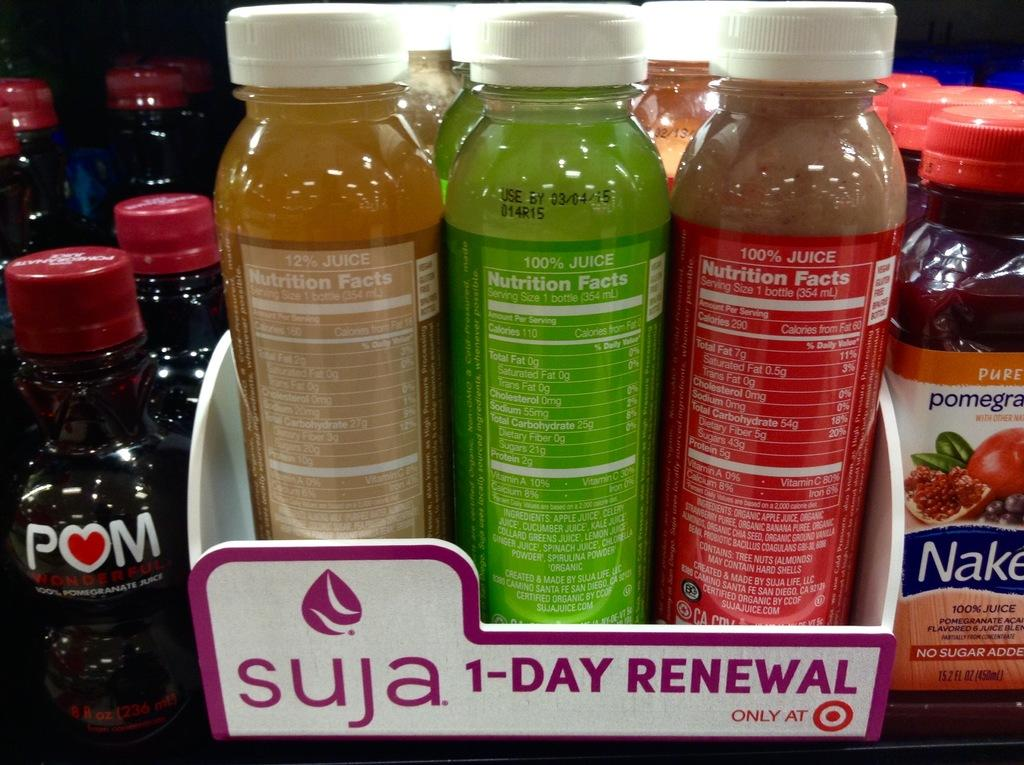Provide a one-sentence caption for the provided image. The water in the box is by the company Suja. 